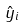<formula> <loc_0><loc_0><loc_500><loc_500>\hat { y } _ { i }</formula> 